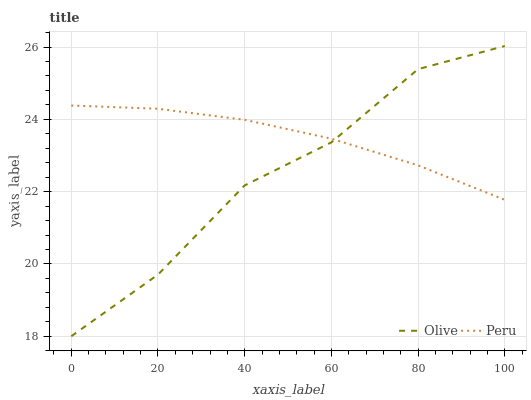Does Olive have the minimum area under the curve?
Answer yes or no. Yes. Does Peru have the maximum area under the curve?
Answer yes or no. Yes. Does Peru have the minimum area under the curve?
Answer yes or no. No. Is Peru the smoothest?
Answer yes or no. Yes. Is Olive the roughest?
Answer yes or no. Yes. Is Peru the roughest?
Answer yes or no. No. Does Olive have the lowest value?
Answer yes or no. Yes. Does Peru have the lowest value?
Answer yes or no. No. Does Olive have the highest value?
Answer yes or no. Yes. Does Peru have the highest value?
Answer yes or no. No. Does Peru intersect Olive?
Answer yes or no. Yes. Is Peru less than Olive?
Answer yes or no. No. Is Peru greater than Olive?
Answer yes or no. No. 